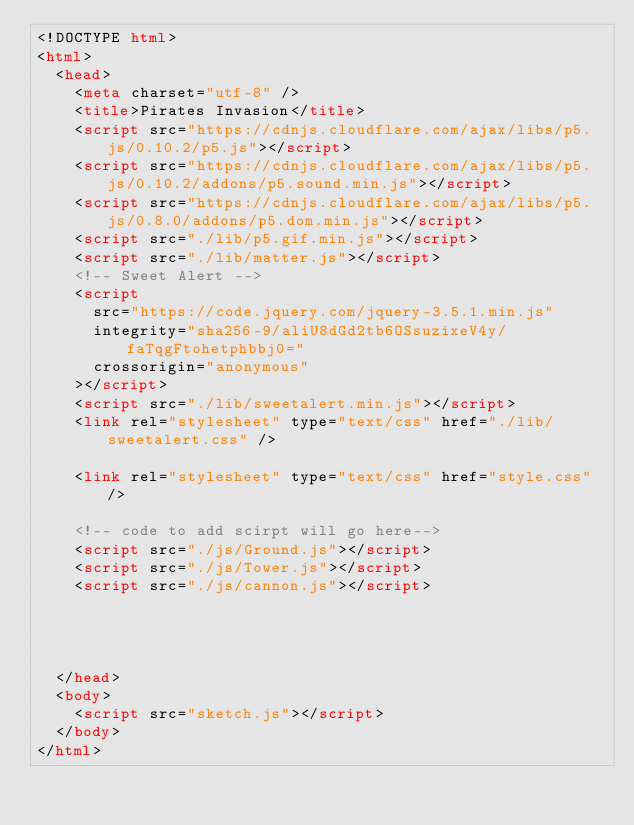<code> <loc_0><loc_0><loc_500><loc_500><_HTML_><!DOCTYPE html>
<html>
  <head>
    <meta charset="utf-8" />
    <title>Pirates Invasion</title>
    <script src="https://cdnjs.cloudflare.com/ajax/libs/p5.js/0.10.2/p5.js"></script>
    <script src="https://cdnjs.cloudflare.com/ajax/libs/p5.js/0.10.2/addons/p5.sound.min.js"></script>
    <script src="https://cdnjs.cloudflare.com/ajax/libs/p5.js/0.8.0/addons/p5.dom.min.js"></script>
    <script src="./lib/p5.gif.min.js"></script>
    <script src="./lib/matter.js"></script>
    <!-- Sweet Alert -->
    <script
      src="https://code.jquery.com/jquery-3.5.1.min.js"
      integrity="sha256-9/aliU8dGd2tb6OSsuzixeV4y/faTqgFtohetphbbj0="
      crossorigin="anonymous"
    ></script>
    <script src="./lib/sweetalert.min.js"></script>
    <link rel="stylesheet" type="text/css" href="./lib/sweetalert.css" />

    <link rel="stylesheet" type="text/css" href="style.css" />

    <!-- code to add scirpt will go here-->
    <script src="./js/Ground.js"></script>
    <script src="./js/Tower.js"></script>
    <script src="./js/cannon.js"></script>
    
   
 
   
  </head>
  <body>
    <script src="sketch.js"></script>
  </body>
</html>
</code> 